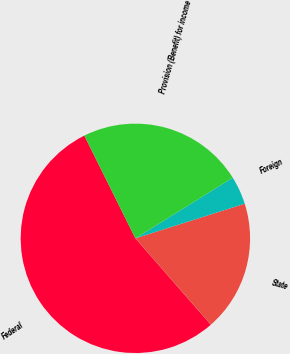Convert chart. <chart><loc_0><loc_0><loc_500><loc_500><pie_chart><fcel>Federal<fcel>State<fcel>Foreign<fcel>Provision (Benefit) for income<nl><fcel>54.08%<fcel>18.46%<fcel>3.98%<fcel>23.47%<nl></chart> 